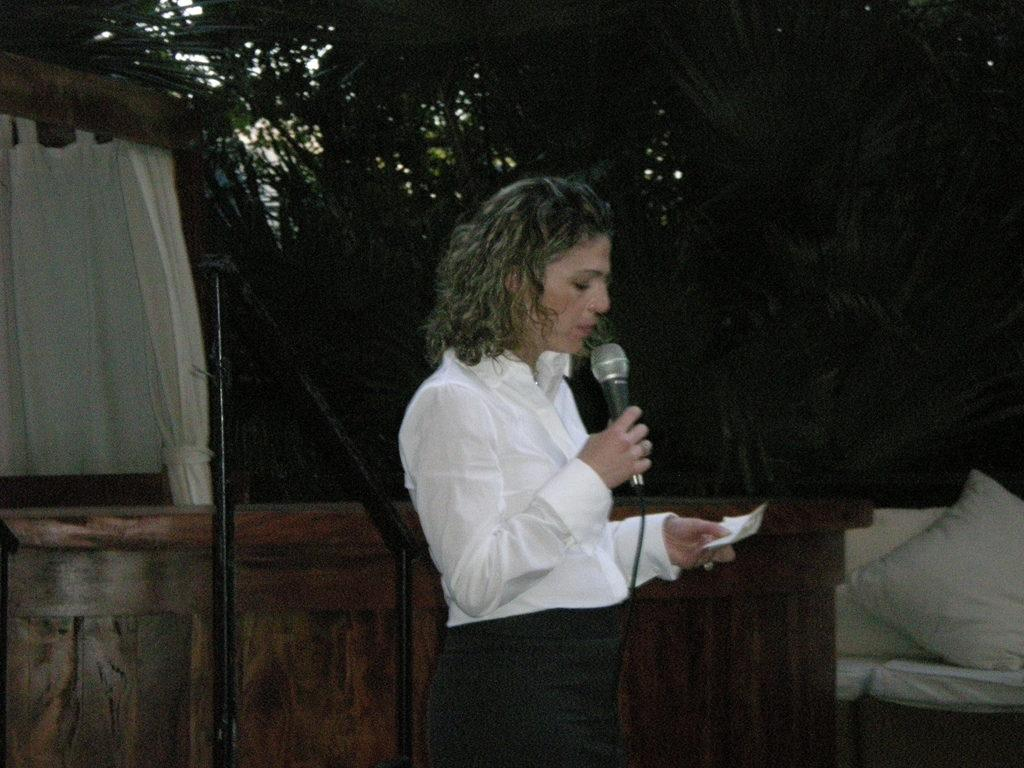Who is the main subject in the image? There is a woman in the image. What is the woman doing in the image? The woman is standing and holding a microphone. What can be seen on the left side of the image? There is a wooden table on the left side of the image. What is present on the right side of the image? There is a white pillow on the right side of the image. How does the crowd react to the woman's speech in the image? There is no crowd present in the image; it only features a woman standing with a microphone. What type of fold can be seen in the pillow on the right side of the image? There is no fold visible in the pillow on the right side of the image; it is a white pillow without any visible creases or folds. 